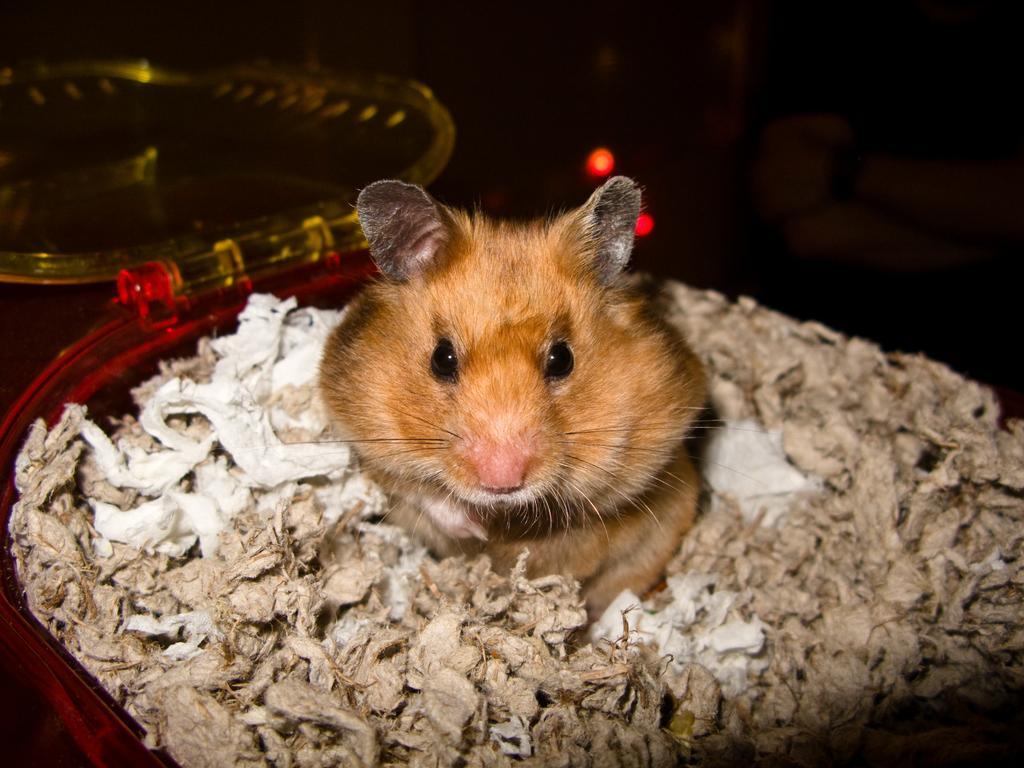In one or two sentences, can you explain what this image depicts? In this picture we can see one rat placed in the basket. 